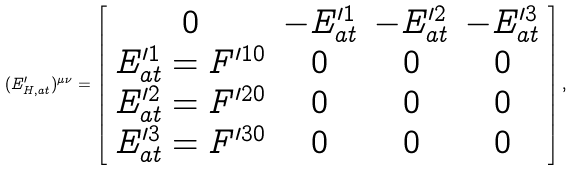<formula> <loc_0><loc_0><loc_500><loc_500>( E _ { H , a t } ^ { \prime } ) ^ { \mu \nu } = \left [ \begin{array} { c c c c } 0 & - E _ { a t } ^ { \prime 1 } & - E _ { a t } ^ { \prime 2 } & - E _ { a t } ^ { \prime 3 } \\ E _ { a t } ^ { \prime 1 } = F ^ { \prime 1 0 } & 0 & 0 & 0 \\ E _ { a t } ^ { \prime 2 } = F ^ { \prime 2 0 } & 0 & 0 & 0 \\ E _ { a t } ^ { \prime 3 } = F ^ { \prime 3 0 } & 0 & 0 & 0 \end{array} \right ] ,</formula> 